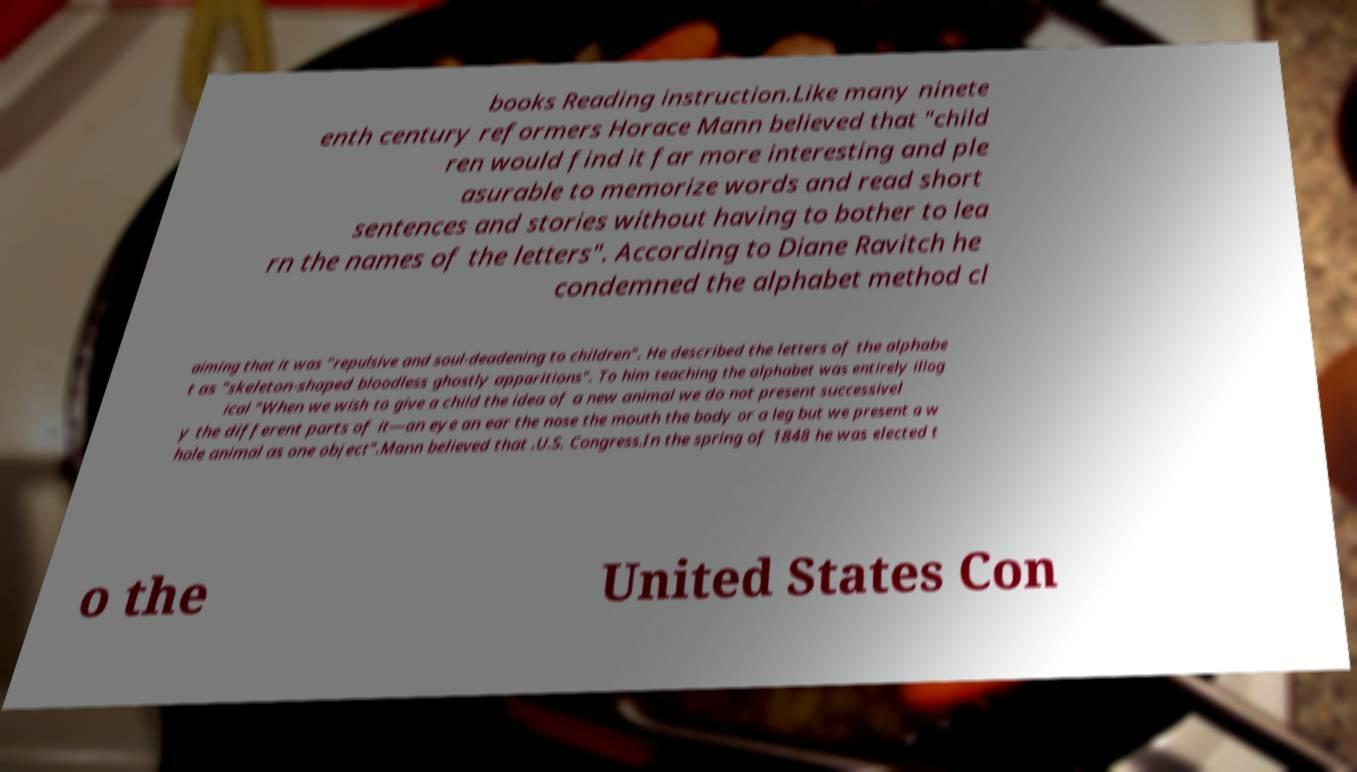I need the written content from this picture converted into text. Can you do that? books Reading instruction.Like many ninete enth century reformers Horace Mann believed that "child ren would find it far more interesting and ple asurable to memorize words and read short sentences and stories without having to bother to lea rn the names of the letters". According to Diane Ravitch he condemned the alphabet method cl aiming that it was "repulsive and soul-deadening to children". He described the letters of the alphabe t as "skeleton-shaped bloodless ghostly apparitions". To him teaching the alphabet was entirely illog ical "When we wish to give a child the idea of a new animal we do not present successivel y the different parts of it—an eye an ear the nose the mouth the body or a leg but we present a w hole animal as one object".Mann believed that .U.S. Congress.In the spring of 1848 he was elected t o the United States Con 